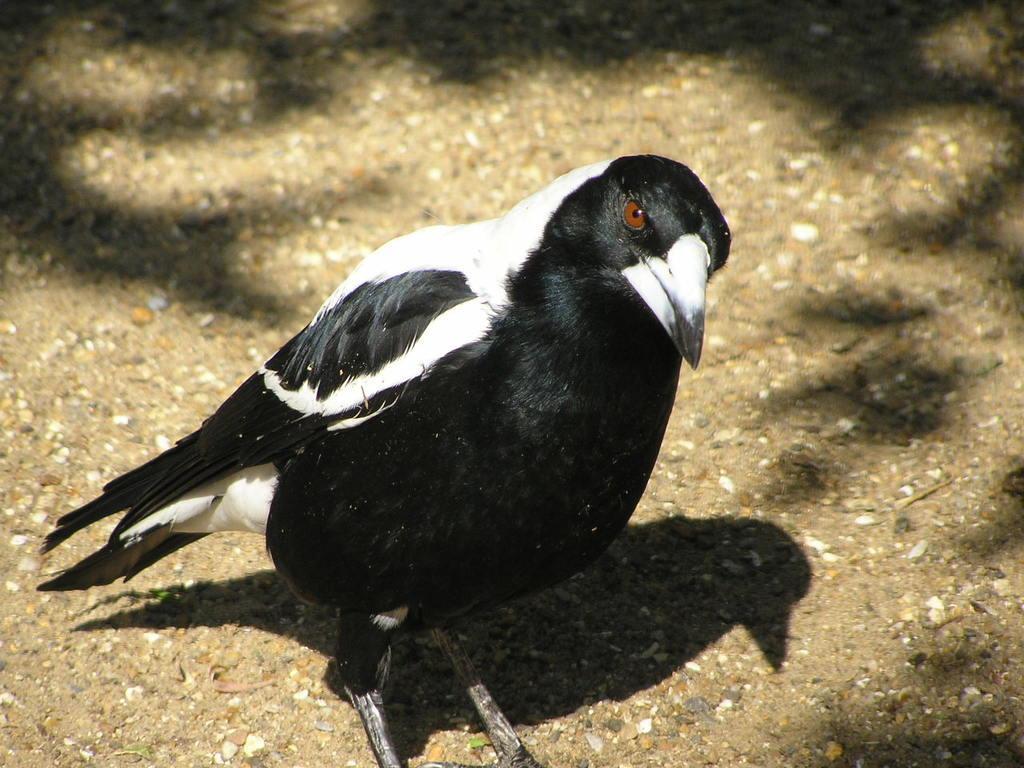Could you give a brief overview of what you see in this image? There is a black and white color bird is on the land. 